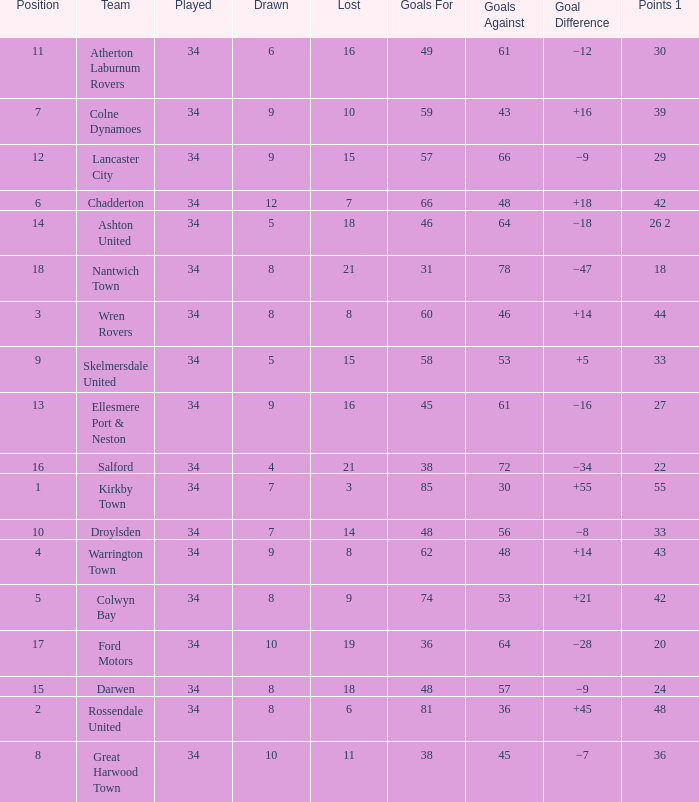What is the total number of goals for when the drawn is less than 7, less than 21 games have been lost, and there are 1 of 33 points? 1.0. 